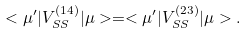Convert formula to latex. <formula><loc_0><loc_0><loc_500><loc_500>< \mu ^ { \prime } | V ^ { ( 1 4 ) } _ { S S } | \mu > = < \mu ^ { \prime } | V ^ { ( 2 3 ) } _ { S S } | \mu > .</formula> 